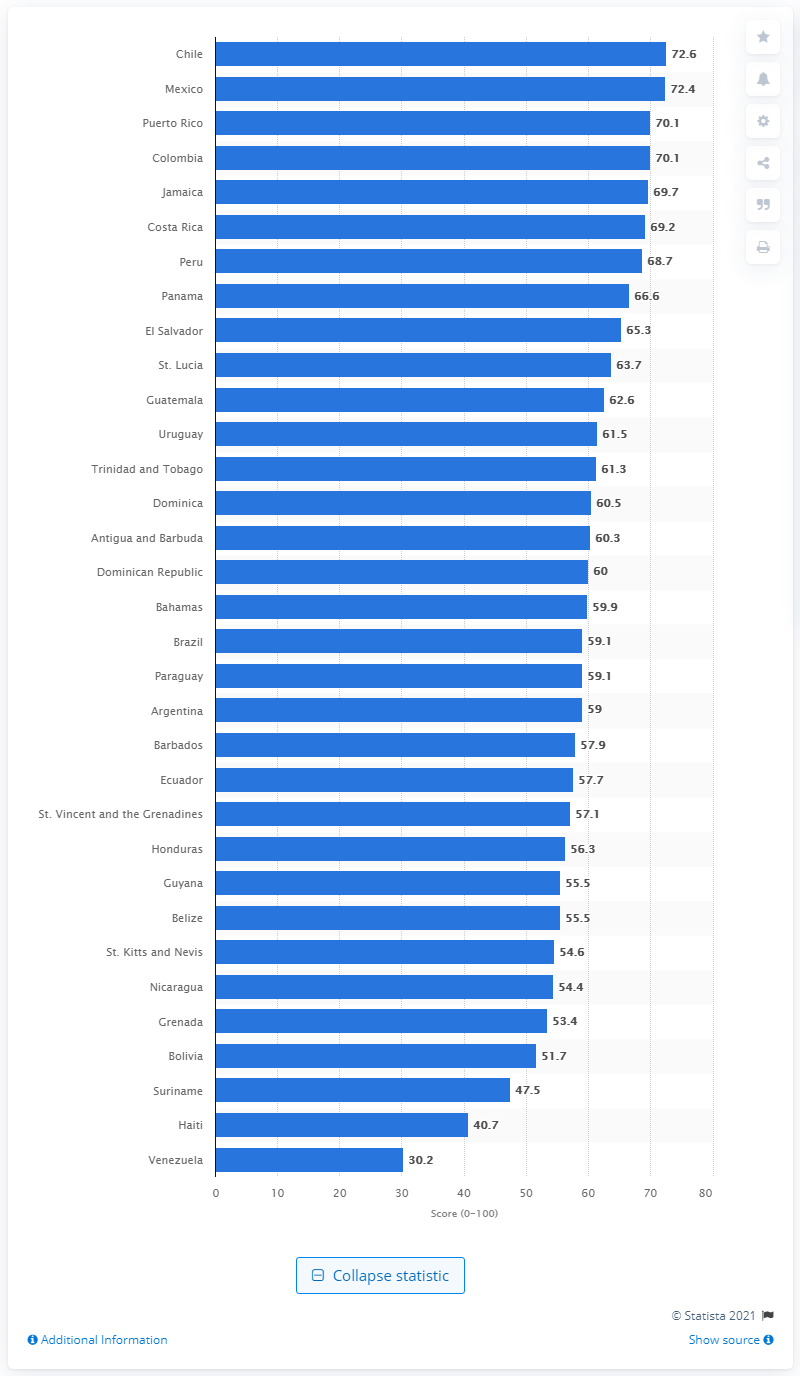Mention a couple of crucial points in this snapshot. In 2019, Venezuela's business-friendliness score was 30.2, indicating a moderate level of support for entrepreneurship and business activity in the country. 